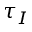Convert formula to latex. <formula><loc_0><loc_0><loc_500><loc_500>\tau _ { I }</formula> 